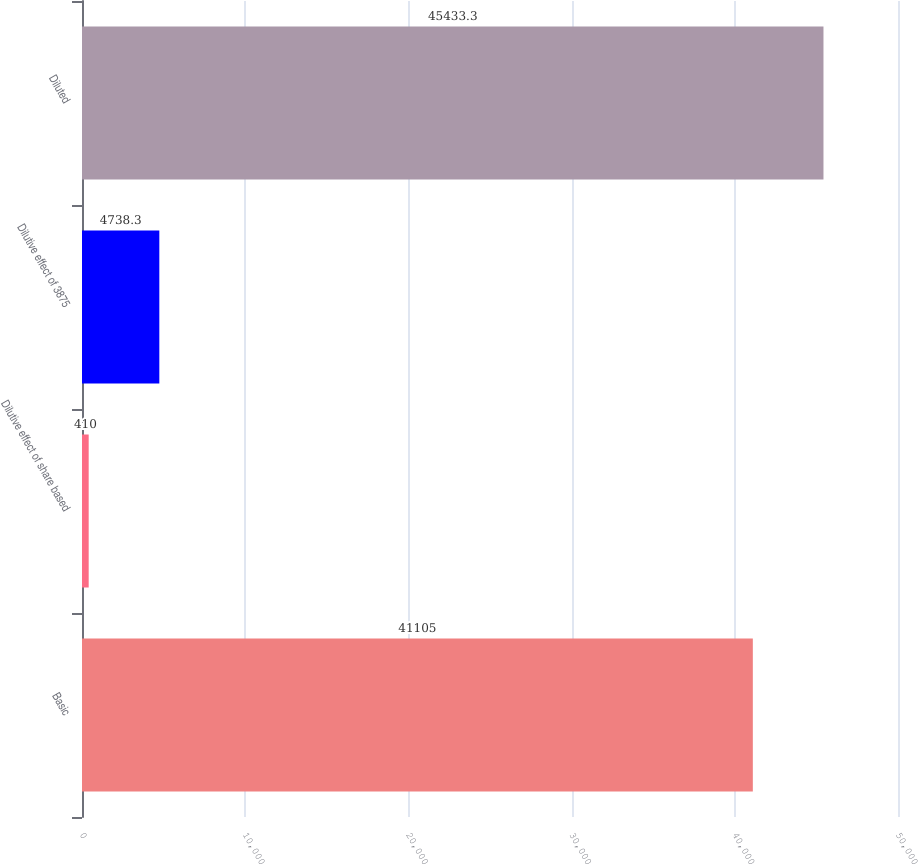Convert chart to OTSL. <chart><loc_0><loc_0><loc_500><loc_500><bar_chart><fcel>Basic<fcel>Dilutive effect of share based<fcel>Dilutive effect of 3875<fcel>Diluted<nl><fcel>41105<fcel>410<fcel>4738.3<fcel>45433.3<nl></chart> 